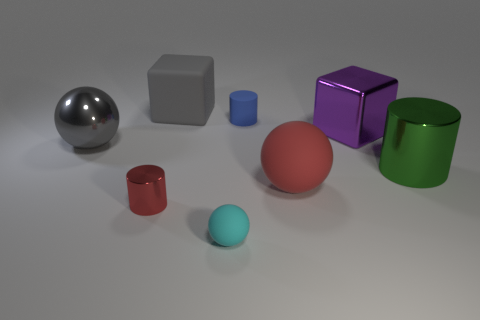What is the color of the tiny rubber ball?
Offer a terse response. Cyan. Does the rubber block have the same color as the big metal cylinder?
Your answer should be very brief. No. How many rubber things are large gray things or red spheres?
Provide a succinct answer. 2. There is a tiny cylinder behind the red matte ball that is to the right of the big shiny ball; are there any blue cylinders to the left of it?
Give a very brief answer. No. What is the size of the blue object that is the same material as the big red object?
Your answer should be compact. Small. Are there any things in front of the blue object?
Your answer should be compact. Yes. Is there a tiny cylinder to the right of the red thing on the right side of the small matte cylinder?
Your answer should be very brief. No. There is a gray object that is behind the large purple object; is it the same size as the cylinder that is behind the purple block?
Keep it short and to the point. No. How many small objects are either gray shiny objects or purple metallic things?
Keep it short and to the point. 0. What is the material of the small red thing in front of the block that is right of the small cyan rubber ball?
Make the answer very short. Metal. 